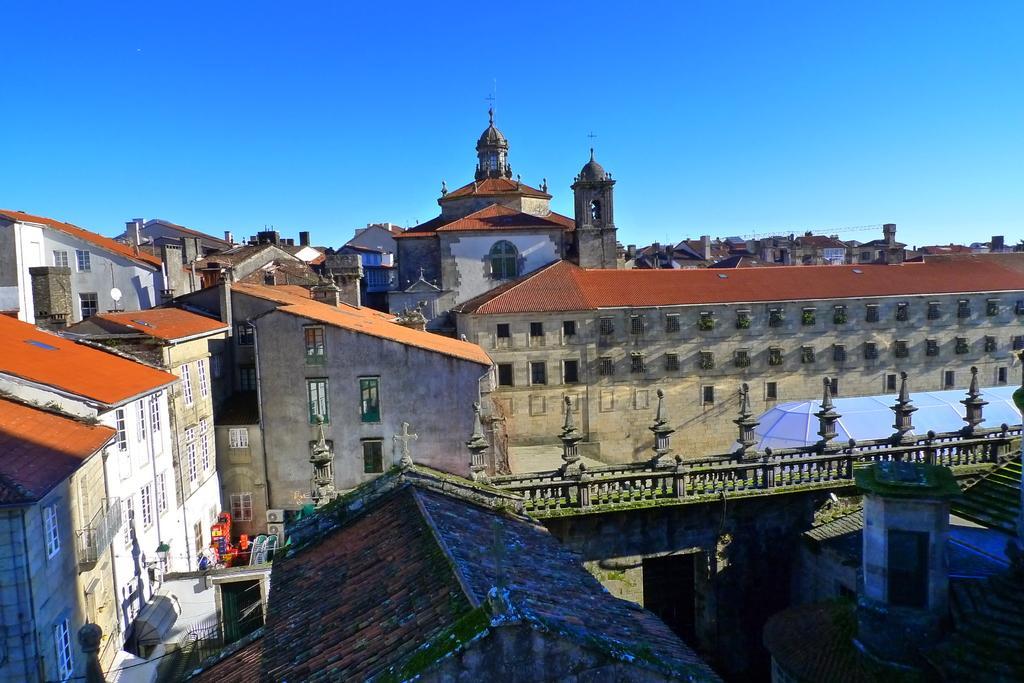How would you summarize this image in a sentence or two? In this image we can see many buildings with windows. Also there are railings. On the railings there are poles. In the background there is sky. 